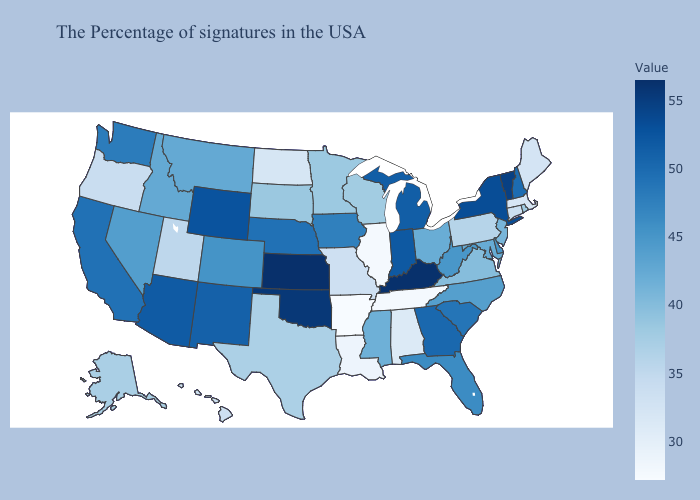Which states hav the highest value in the MidWest?
Short answer required. Kansas. Among the states that border Indiana , does Michigan have the highest value?
Give a very brief answer. No. Among the states that border Kansas , which have the highest value?
Give a very brief answer. Oklahoma. Does Wisconsin have a higher value than Hawaii?
Give a very brief answer. Yes. Which states have the highest value in the USA?
Keep it brief. Kansas. Among the states that border Utah , does Wyoming have the lowest value?
Write a very short answer. No. Does Idaho have a lower value than Indiana?
Concise answer only. Yes. Among the states that border Oklahoma , which have the lowest value?
Write a very short answer. Arkansas. Is the legend a continuous bar?
Give a very brief answer. Yes. 